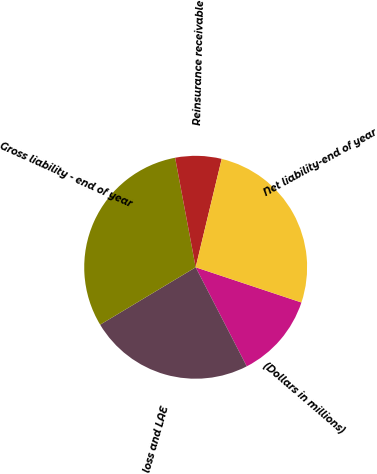Convert chart to OTSL. <chart><loc_0><loc_0><loc_500><loc_500><pie_chart><fcel>(Dollars in millions)<fcel>loss and LAE<fcel>Gross liability - end of year<fcel>Reinsurance receivable<fcel>Net liability-end of year<nl><fcel>12.31%<fcel>23.96%<fcel>30.66%<fcel>6.7%<fcel>26.36%<nl></chart> 